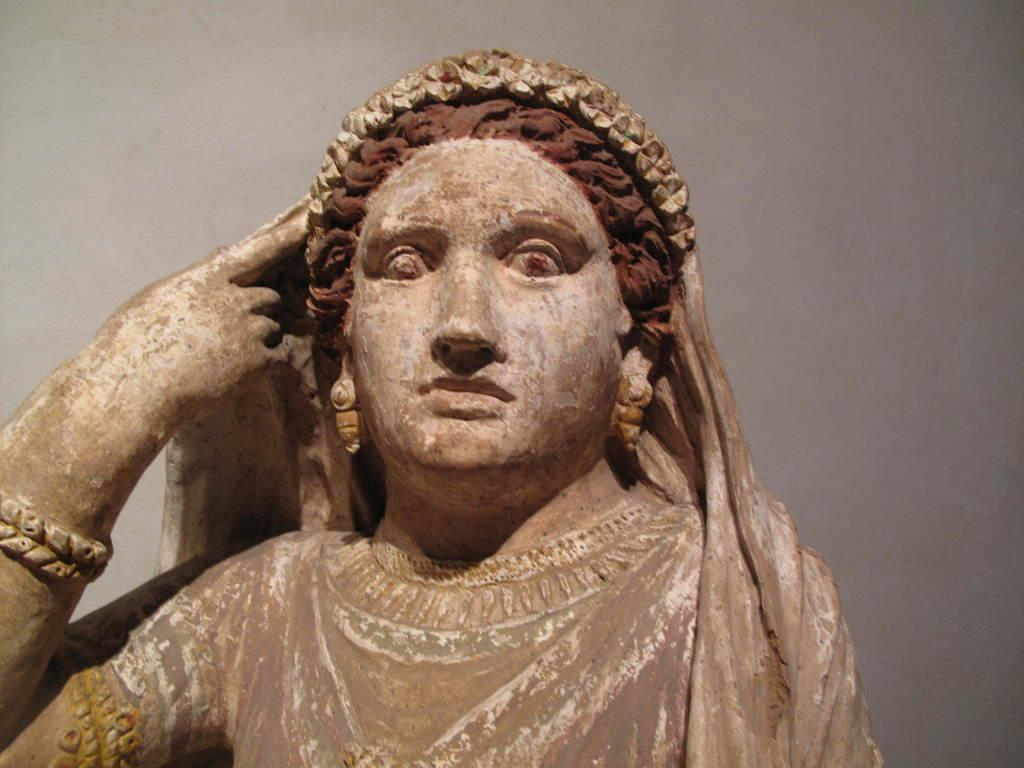What is the main subject in the foreground of the image? There is a sculpture of a woman in the foreground of the image. What color is the background of the image? The background of the image is white in color. Can you describe the setting of the image? The image may have been taken in a hall, based on the available information. What type of operation is being performed on the sculpture in the image? There is no operation being performed on the sculpture in the image; it is a static sculpture. Is the sculpture in motion in the image? The sculpture is not in motion in the image; it is a stationary object. 